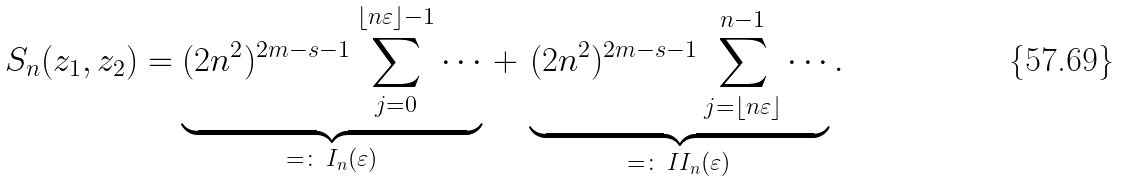<formula> <loc_0><loc_0><loc_500><loc_500>S _ { n } ( z _ { 1 } , z _ { 2 } ) & = \underbrace { ( 2 n ^ { 2 } ) ^ { 2 m - s - 1 } \sum _ { j = 0 } ^ { \lfloor n \varepsilon \rfloor - 1 } \cdots } _ { = \colon \, I _ { n } ( \varepsilon ) } \, + \, \underbrace { ( 2 n ^ { 2 } ) ^ { 2 m - s - 1 } \sum _ { j = \lfloor n \varepsilon \rfloor } ^ { n - 1 } \cdots } _ { = \colon \, I I _ { n } ( \varepsilon ) } .</formula> 